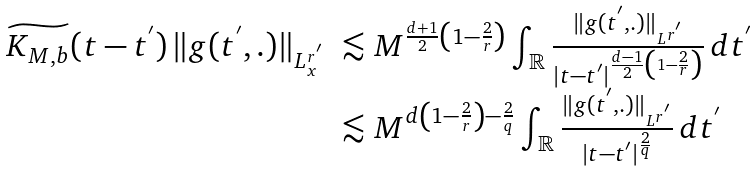Convert formula to latex. <formula><loc_0><loc_0><loc_500><loc_500>\begin{array} { l l } \widetilde { K _ { M , b } } ( t - t ^ { ^ { \prime } } ) \, \| g ( t ^ { ^ { \prime } } , . ) \| _ { L _ { x } ^ { r ^ { ^ { \prime } } } } & \lesssim M ^ { \frac { d + 1 } { 2 } \left ( 1 - \frac { 2 } { r } \right ) } \int _ { \mathbb { R } } \frac { \| g ( t ^ { ^ { \prime } } , . ) \| _ { L ^ { r ^ { ^ { \prime } } } } } { | t - t ^ { ^ { \prime } } | ^ { \frac { d - 1 } { 2 } \left ( 1 - \frac { 2 } { r } \right ) } } \, d t ^ { ^ { \prime } } \\ & \lesssim M ^ { d \left ( 1 - \frac { 2 } { r } \right ) - \frac { 2 } { q } } \int _ { \mathbb { R } } \frac { \| g ( t ^ { ^ { \prime } } , . ) \| _ { L ^ { r ^ { ^ { \prime } } } } } { | t - t ^ { ^ { \prime } } | ^ { \frac { 2 } { q } } } \, d t ^ { ^ { \prime } } \\ \end{array}</formula> 